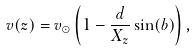Convert formula to latex. <formula><loc_0><loc_0><loc_500><loc_500>v ( z ) = v _ { \odot } \left ( 1 - \frac { d } { X _ { z } } \sin ( b ) \right ) ,</formula> 